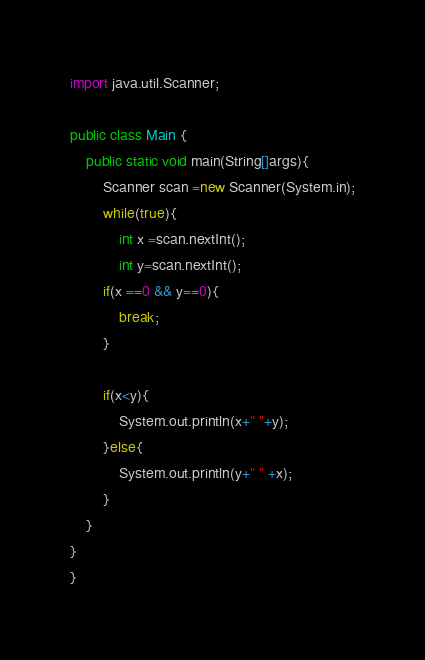Convert code to text. <code><loc_0><loc_0><loc_500><loc_500><_Java_>import java.util.Scanner;

public class Main {	
	public static void main(String[]args){
		Scanner scan =new Scanner(System.in);
		while(true){
			int x =scan.nextInt();
			int y=scan.nextInt();
		if(x ==0 && y==0){
			break;
		}	
			
		if(x<y){
			System.out.println(x+" "+y);
		}else{
			System.out.println(y+" " +x);
		}
	}
}
}</code> 